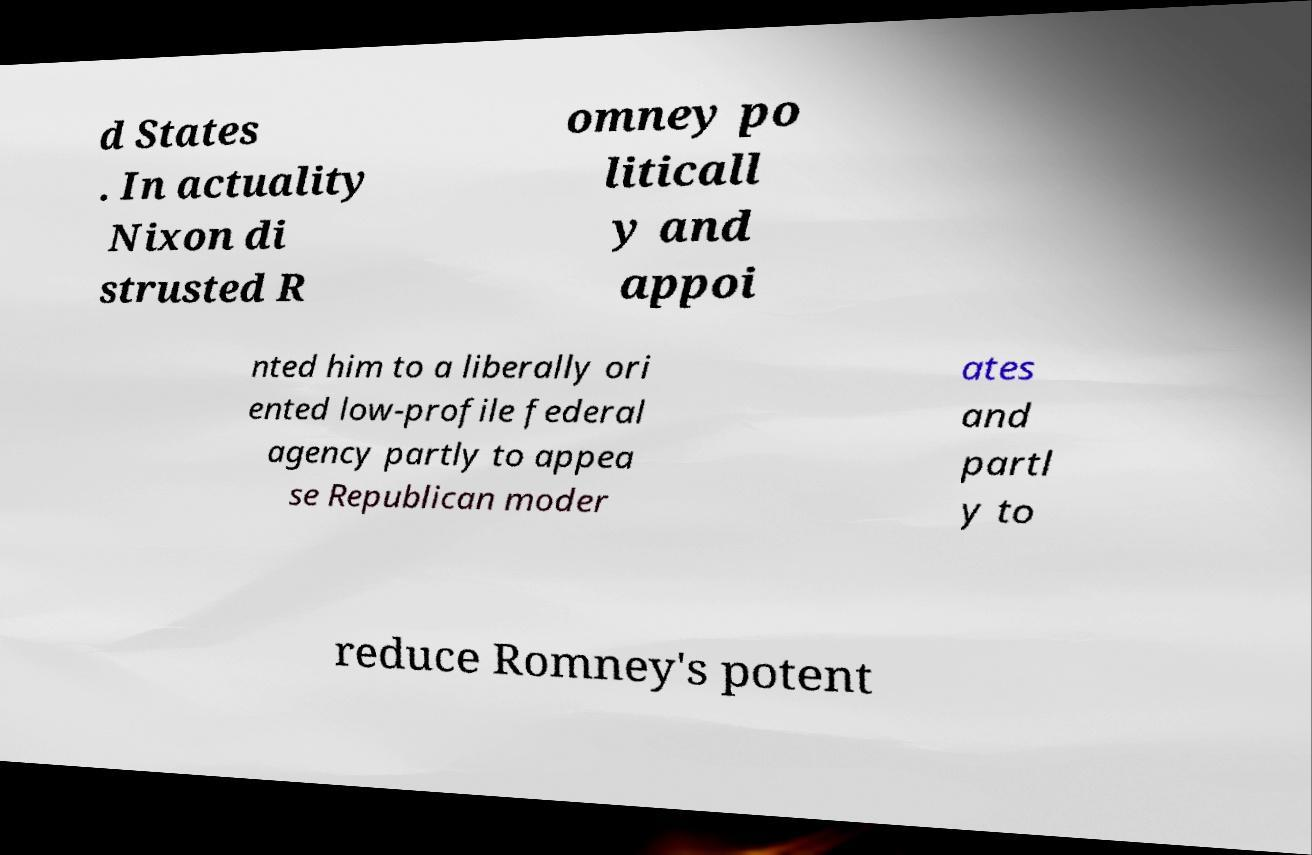For documentation purposes, I need the text within this image transcribed. Could you provide that? d States . In actuality Nixon di strusted R omney po liticall y and appoi nted him to a liberally ori ented low-profile federal agency partly to appea se Republican moder ates and partl y to reduce Romney's potent 